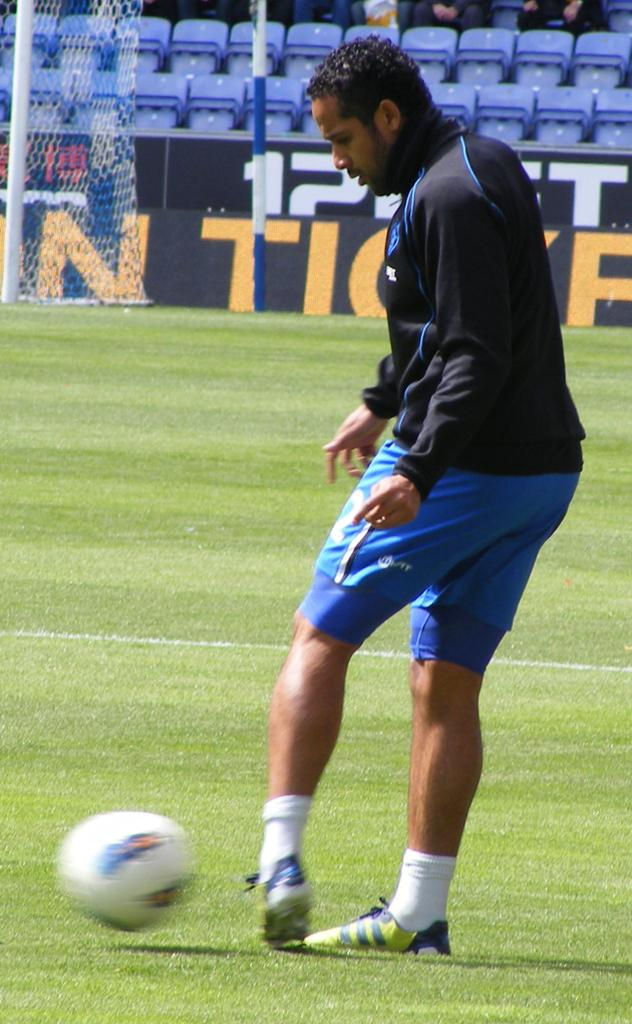What is the person in the image doing? The person is standing on the grass and trying to hit a ball. What can be seen in the background of the image? There are hoardings, a net, poles, and seats in the background. What is the purpose of the net in the background? The net in the background is likely used for separating the playing area or catching the ball. What are the people sitting on in the background? The people sitting on seats in the background. How many frogs can be seen hopping on the grass in the image? There are no frogs visible in the image; it features a person trying to hit a ball on the grass. 